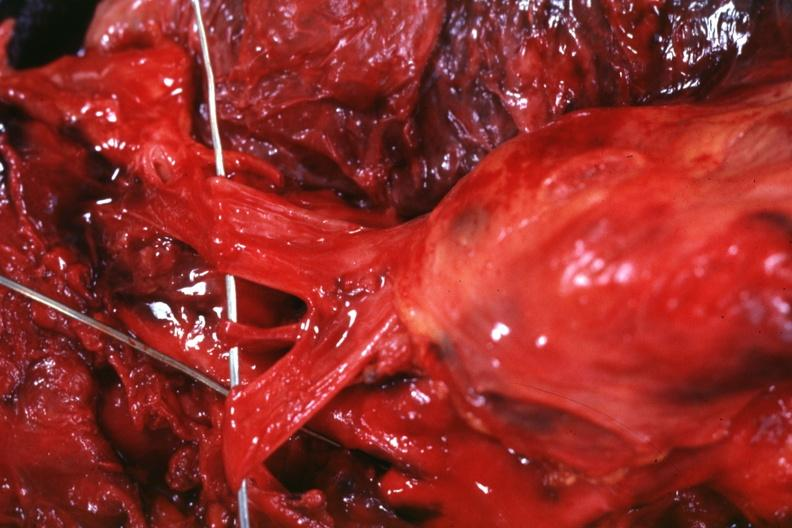s ovary invaded by the tumor?
Answer the question using a single word or phrase. No 